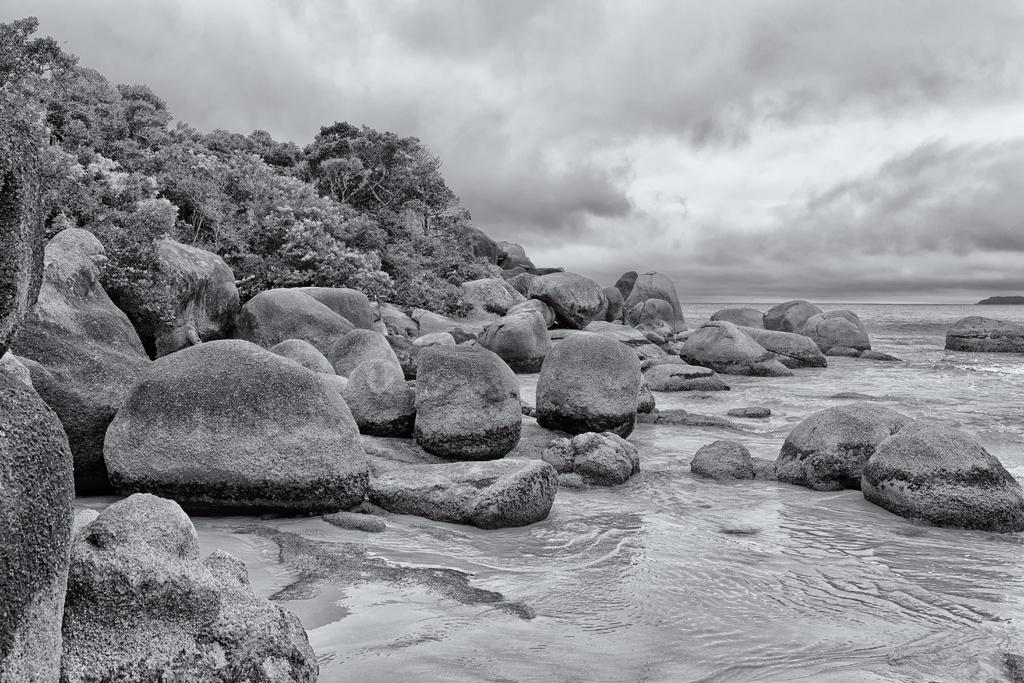What can be seen in the middle of the image? There are trees, stones, and waves in the middle of the image. What type of natural environment is depicted in the image? The image features water, trees, and stones, suggesting a coastal or beach setting. What is visible at the top of the image? The sky is visible at the top of the image. What can be observed in the sky? Clouds are present in the sky. Is there a sidewalk leading to the water in the image? There is no sidewalk present in the image. Can you see a scarecrow standing among the trees in the image? There is no scarecrow present in the image. 